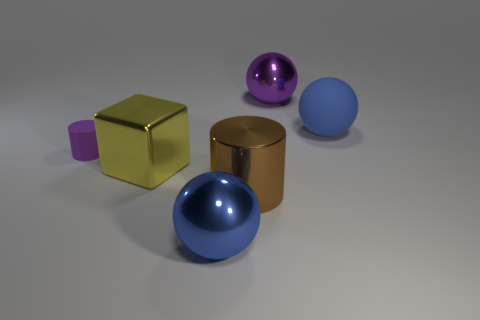Subtract all rubber spheres. How many spheres are left? 2 Add 4 tiny cyan things. How many objects exist? 10 Subtract all green cylinders. How many blue balls are left? 2 Subtract all blocks. How many objects are left? 5 Add 3 tiny purple cylinders. How many tiny purple cylinders are left? 4 Add 6 big blue matte blocks. How many big blue matte blocks exist? 6 Subtract all purple balls. How many balls are left? 2 Subtract 1 yellow blocks. How many objects are left? 5 Subtract all cyan blocks. Subtract all green balls. How many blocks are left? 1 Subtract all red metal cylinders. Subtract all yellow metal objects. How many objects are left? 5 